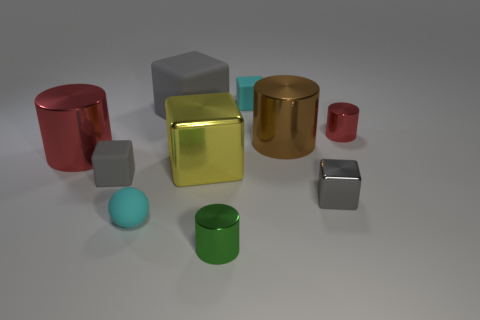What material is the large gray thing?
Ensure brevity in your answer.  Rubber. What material is the cyan object in front of the tiny rubber block right of the rubber cube that is left of the small matte ball?
Your answer should be very brief. Rubber. There is a red thing that is the same size as the green thing; what is its shape?
Provide a short and direct response. Cylinder. How many things are big brown matte cylinders or small gray blocks right of the brown thing?
Give a very brief answer. 1. Is the material of the cyan thing that is in front of the large red cylinder the same as the tiny cylinder that is behind the big yellow metal cube?
Ensure brevity in your answer.  No. The tiny thing that is the same color as the sphere is what shape?
Offer a terse response. Cube. What number of blue objects are metal objects or big metallic cylinders?
Your answer should be compact. 0. What is the size of the cyan matte block?
Your answer should be compact. Small. Are there more big red things behind the cyan rubber block than big shiny objects?
Offer a very short reply. No. There is a yellow block; what number of tiny cyan objects are on the right side of it?
Your response must be concise. 1. 